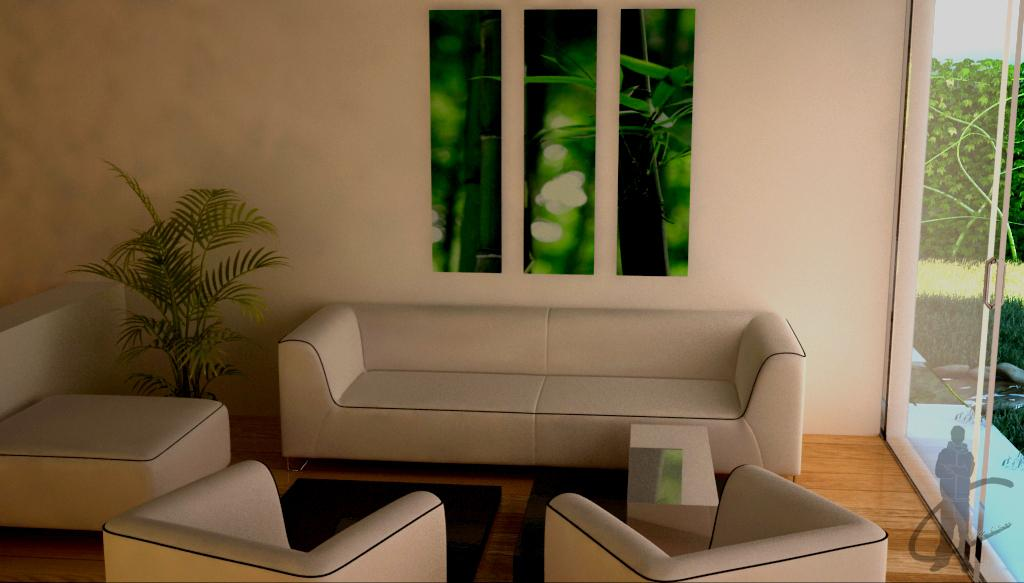What type of furniture is in the room? There is a sofa set in the room. What is located beside the sofa? There is a plant beside the sofa. What decorative item is present on the wall? There is a wall poster in the room. What feature allows natural light into the room? There is a window in the room. What can be seen through the window? Grass and small plants are visible through the window. What type of boundary can be seen in the image? There is no boundary visible in the image; it features a room with a sofa, plant, wall poster, window, and view of grass and small plants. How many houses are visible in the image? There are no houses visible in the image; it features a room with a sofa, plant, wall poster, window, and view of grass and small plants. 